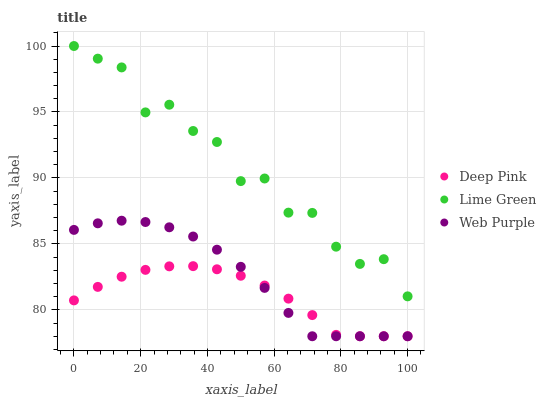Does Deep Pink have the minimum area under the curve?
Answer yes or no. Yes. Does Lime Green have the maximum area under the curve?
Answer yes or no. Yes. Does Lime Green have the minimum area under the curve?
Answer yes or no. No. Does Deep Pink have the maximum area under the curve?
Answer yes or no. No. Is Deep Pink the smoothest?
Answer yes or no. Yes. Is Lime Green the roughest?
Answer yes or no. Yes. Is Lime Green the smoothest?
Answer yes or no. No. Is Deep Pink the roughest?
Answer yes or no. No. Does Web Purple have the lowest value?
Answer yes or no. Yes. Does Lime Green have the lowest value?
Answer yes or no. No. Does Lime Green have the highest value?
Answer yes or no. Yes. Does Deep Pink have the highest value?
Answer yes or no. No. Is Deep Pink less than Lime Green?
Answer yes or no. Yes. Is Lime Green greater than Web Purple?
Answer yes or no. Yes. Does Web Purple intersect Deep Pink?
Answer yes or no. Yes. Is Web Purple less than Deep Pink?
Answer yes or no. No. Is Web Purple greater than Deep Pink?
Answer yes or no. No. Does Deep Pink intersect Lime Green?
Answer yes or no. No. 